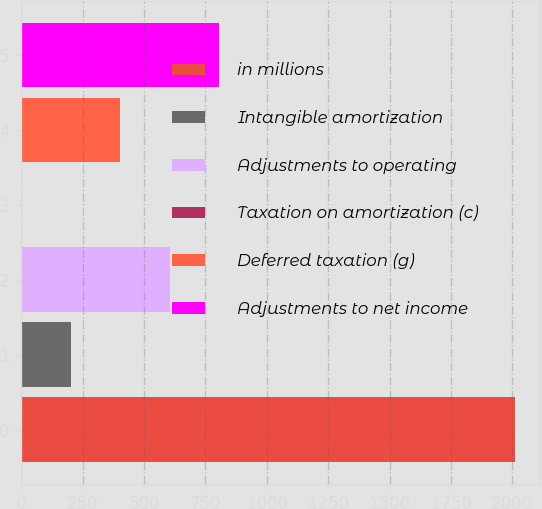<chart> <loc_0><loc_0><loc_500><loc_500><bar_chart><fcel>in millions<fcel>Intangible amortization<fcel>Adjustments to operating<fcel>Taxation on amortization (c)<fcel>Deferred taxation (g)<fcel>Adjustments to net income<nl><fcel>2013<fcel>202.65<fcel>604.95<fcel>1.5<fcel>403.8<fcel>806.1<nl></chart> 